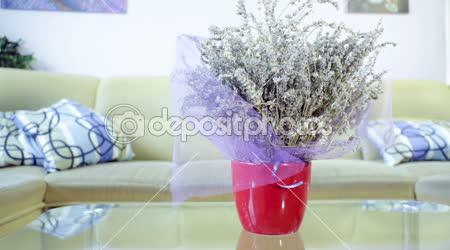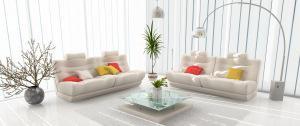The first image is the image on the left, the second image is the image on the right. For the images displayed, is the sentence "there are white columns behind a sofa" factually correct? Answer yes or no. No. The first image is the image on the left, the second image is the image on the right. Evaluate the accuracy of this statement regarding the images: "The pillows in the left image match the sofa.". Is it true? Answer yes or no. No. 